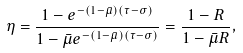Convert formula to latex. <formula><loc_0><loc_0><loc_500><loc_500>\eta = \frac { 1 - e ^ { - ( 1 - \bar { \mu } ) ( \tau - \sigma ) } } { 1 - \bar { \mu } e ^ { - ( 1 - \bar { \mu } ) ( \tau - \sigma ) } } = \frac { 1 - R } { 1 - \bar { \mu } R } ,</formula> 